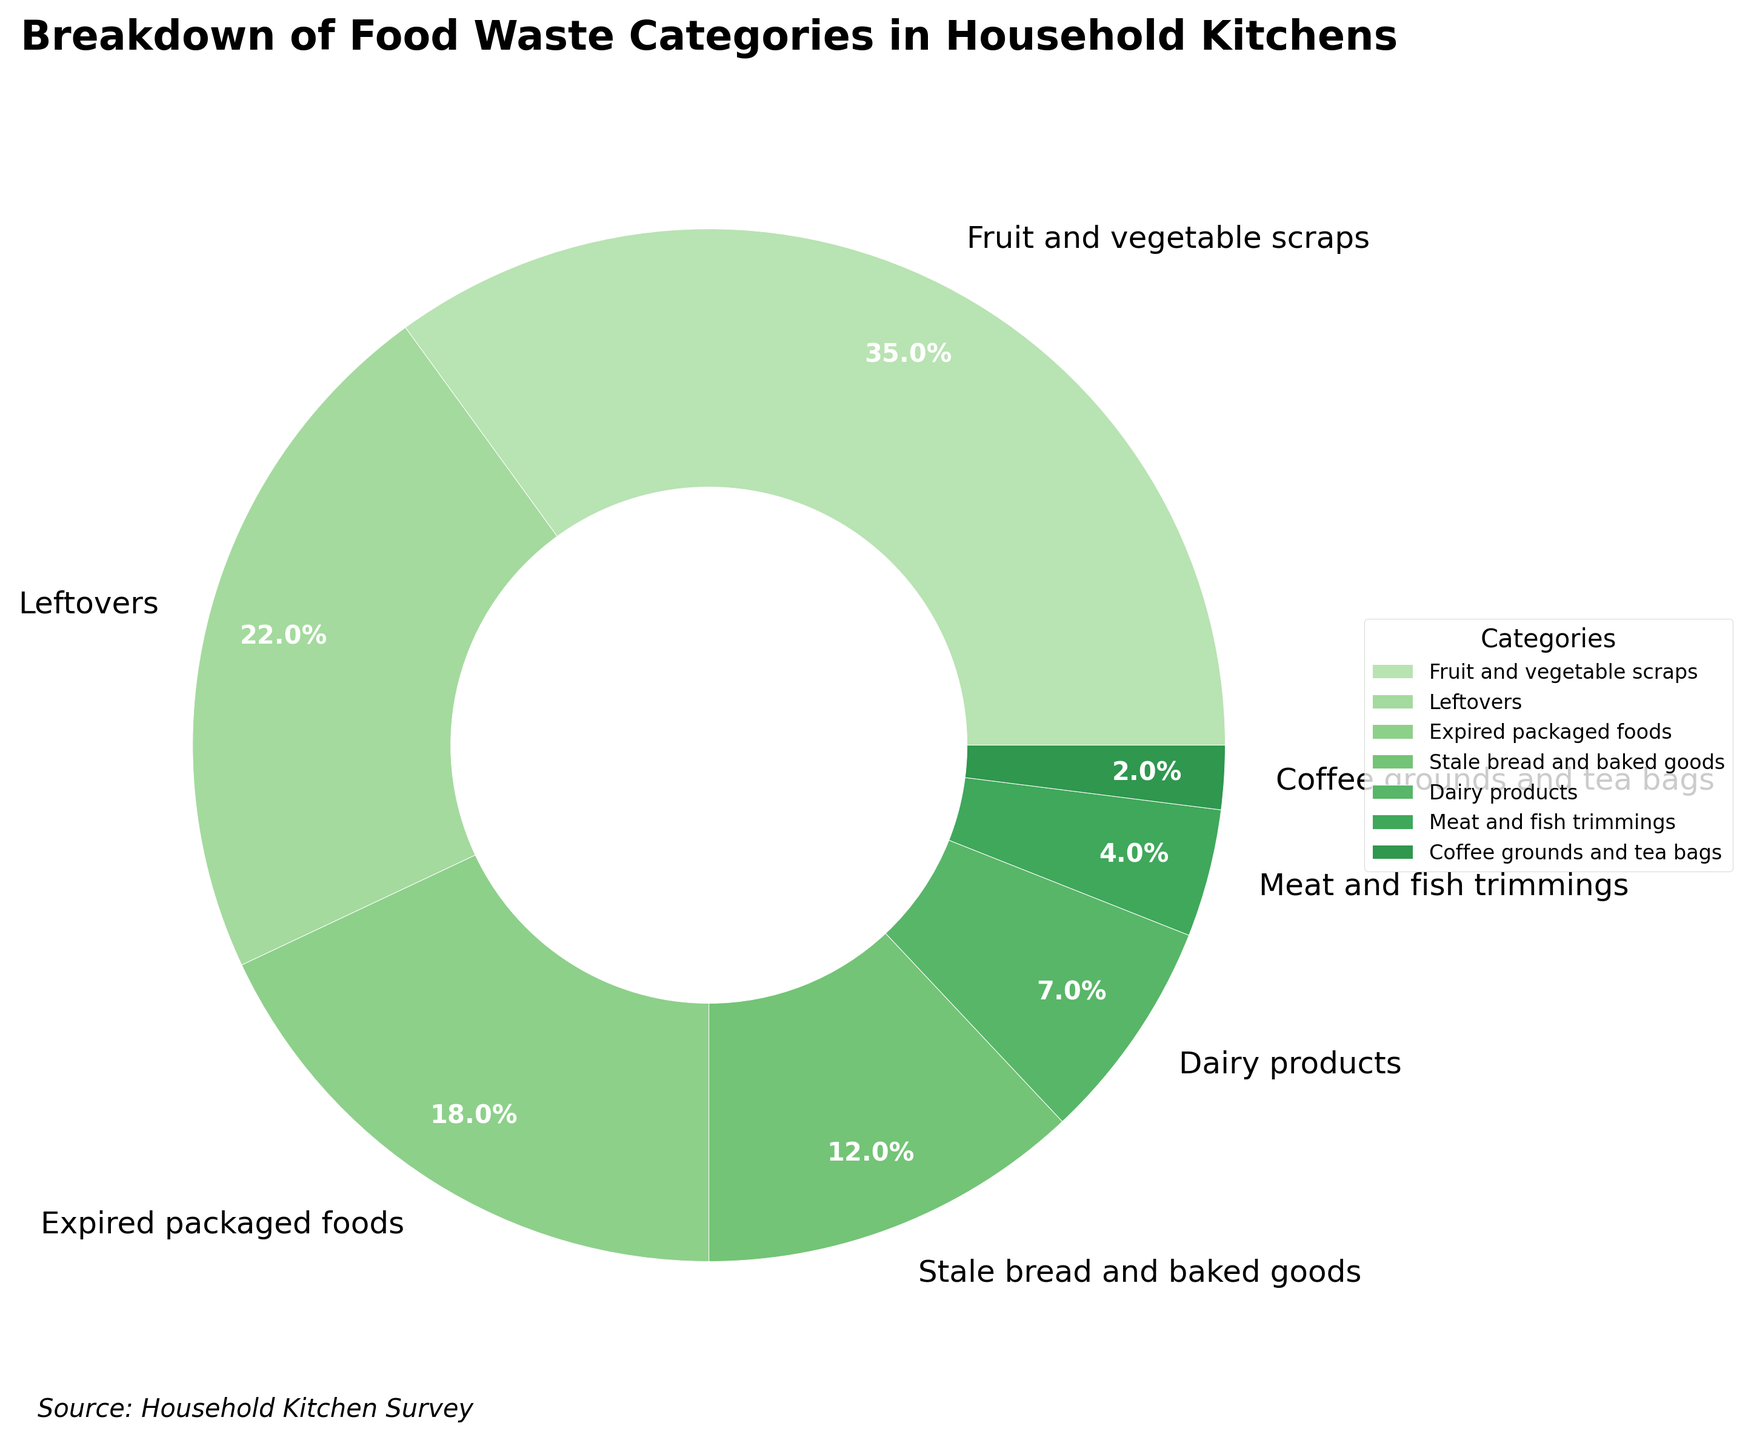Which category contributes the most to household food waste? Look at the pie chart and identify the category with the largest wedge. The "Fruit and vegetable scraps" category has the largest percentage.
Answer: Fruit and vegetable scraps What is the combined percentage for "Leftovers" and "Expired packaged foods"? Add the percentages for "Leftovers" and "Expired packaged foods". Leftovers (22%) + Expired packaged foods (18%) = 40%.
Answer: 40% Which category has the smallest contribution to household food waste? Find the category with the smallest wedge in the pie chart. "Coffee grounds and tea bags" has the smallest percentage.
Answer: Coffee grounds and tea bags Are "Stale bread and baked goods" responsible for more food waste than "Dairy products"? Compare the percentages of these two categories in the pie chart. Stale bread and baked goods (12%) is greater than Dairy products (7%).
Answer: Yes How much more waste do "Fruit and vegetable scraps" contribute compared to "Meat and fish trimmings"? Subtract the percentage of "Meat and fish trimmings" from that of "Fruit and vegetable scraps". 35% - 4% = 31%.
Answer: 31% Which two categories combined are responsible for 26% of the food waste? Look at the individual percentages and find a combination that sums to 26%. "Dairy products" (7%) + "Expired packaged foods" (18%) = 25%, which is closest, but not exactly 26%. Try all combinations and you'll find none exactly sums to 26%.
Answer: None Which has a higher percentage: "Expired packaged foods" or the sum of "Meat and fish trimmings" and "Coffee grounds and tea bags"? Compare "Expired packaged foods" (18%) with the sum of "Meat and fish trimmings" (4%) and "Coffee grounds and tea bags" (2%). 4% + 2% = 6%, which is less than 18%.
Answer: Expired packaged foods By how much does the percentage of "Leftovers" exceed that of "Dairy products"? Subtract the percentage of "Dairy products" from "Leftovers". Leftovers (22%) - Dairy products (7%) = 15%.
Answer: 15% What are the three top contributors to household food waste? Identify the top three categories based on their percentages. "Fruit and vegetable scraps" (35%), "Leftovers" (22%), and "Expired packaged foods" (18%).
Answer: Fruit and vegetable scraps, Leftovers, Expired packaged foods What is the percentage difference between "Stale bread and baked goods" and "Coffee grounds and tea bags"? Subtract the percentage of "Coffee grounds and tea bags" from "Stale bread and baked goods". Stale bread and baked goods (12%) - Coffee grounds and tea bags (2%) = 10%.
Answer: 10% 